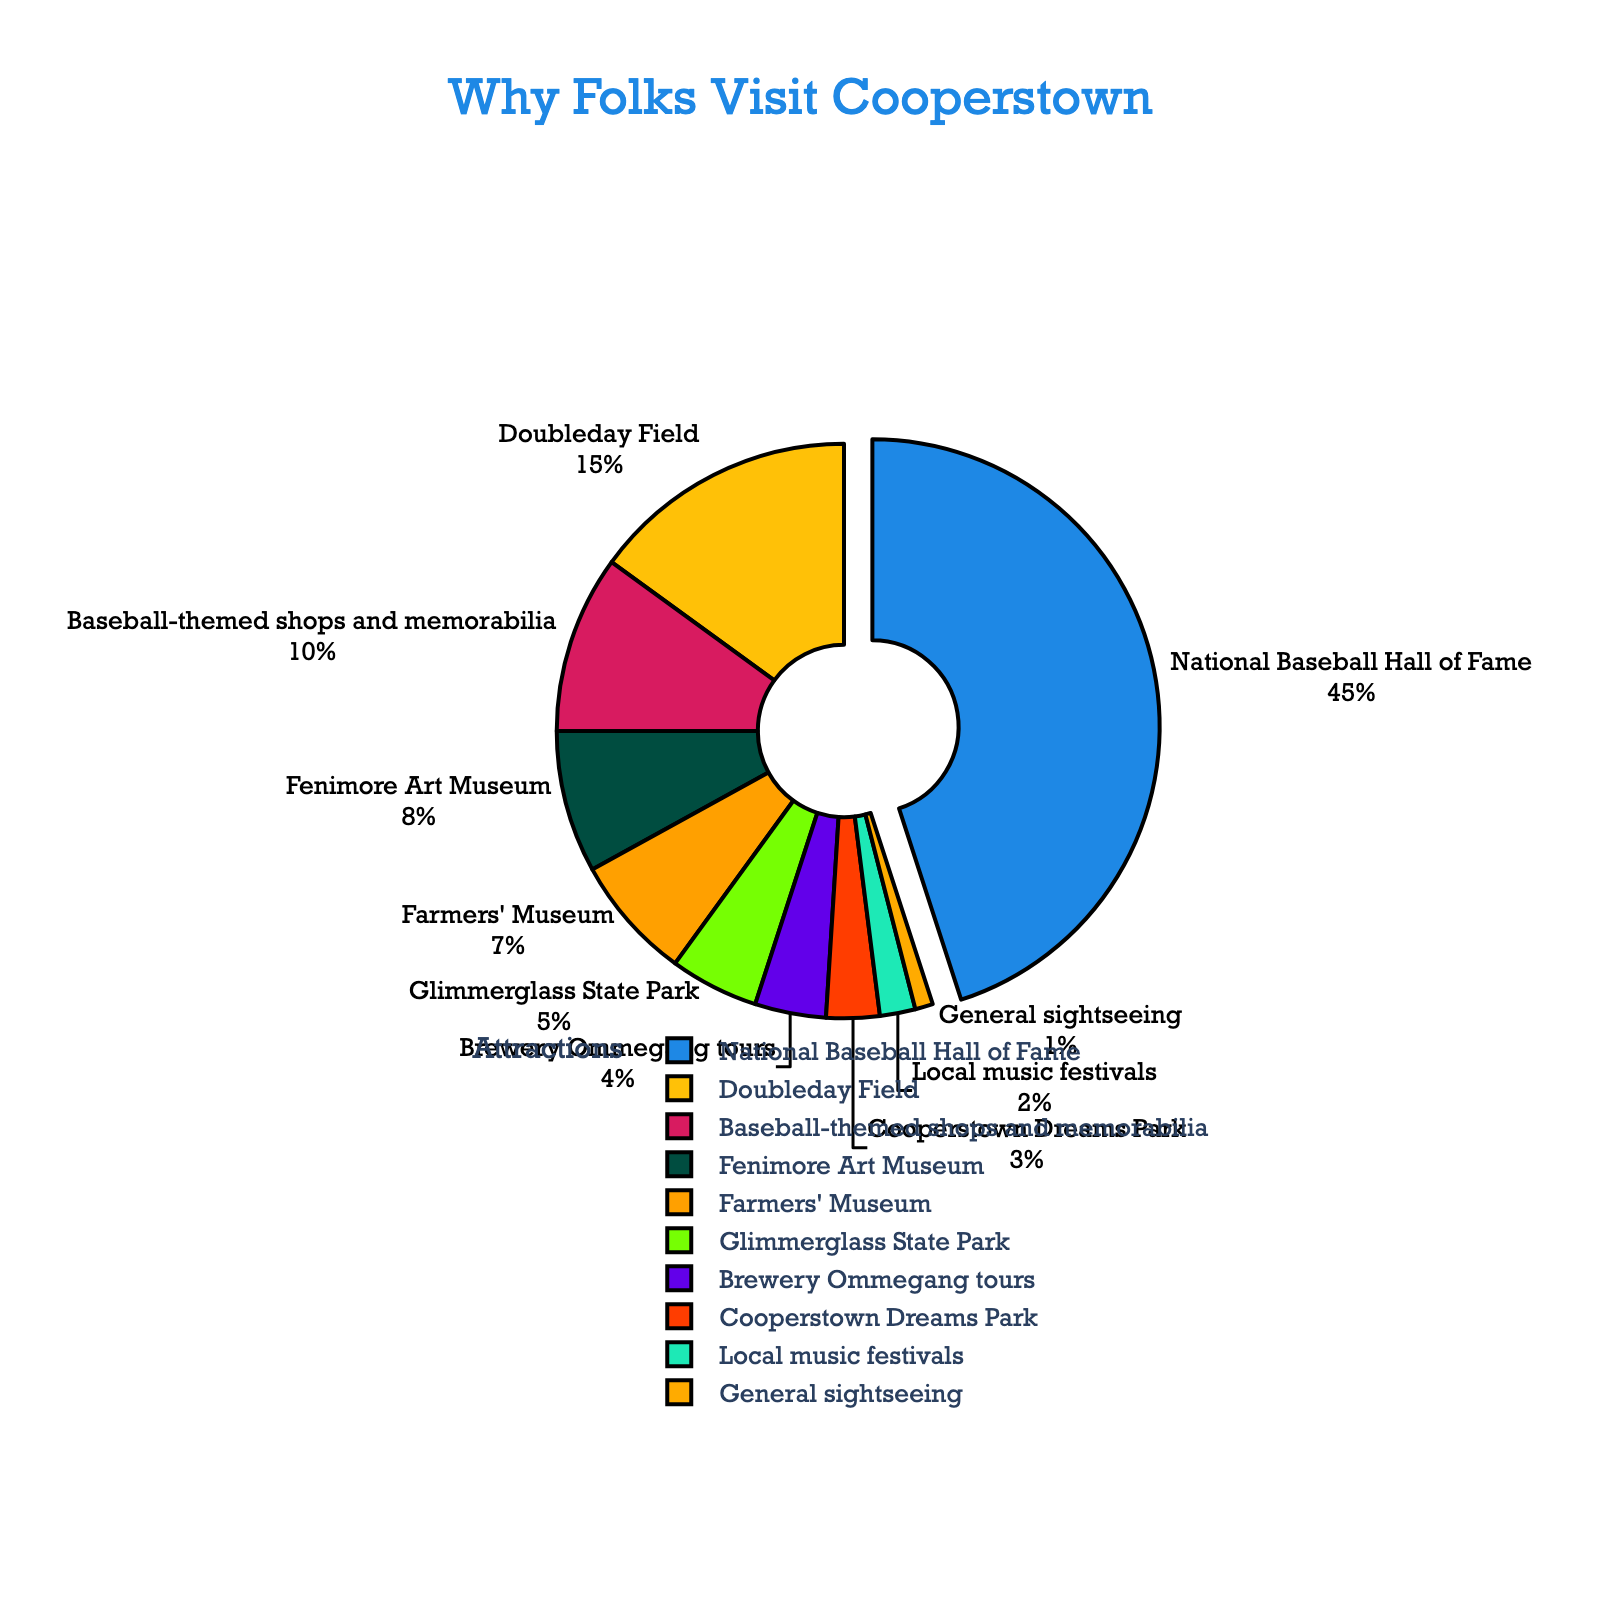What percentage of tourists visit Cooperstown for National Baseball Hall of Fame? The slice of the pie representing the National Baseball Hall of Fame is labeled with a percentage.
Answer: 45% What is the combined percentage of tourists visiting Cooperstown for baseball-related attractions? The baseball-related attractions include the National Baseball Hall of Fame (45%), Doubleday Field (15%), and Baseball-themed shops and memorabilia (10%). Sum these percentages: 45% + 15% + 10% = 70%.
Answer: 70% Which attraction draws the least percentage of tourists? The smallest slice of the pie chart is labeled "General sightseeing" with a percentage of 1%.
Answer: General sightseeing How does the percentage of tourists visiting Doubleday Field compare to those visiting the Farmers' Museum? The slice for Doubleday Field is labeled with 15%, and the slice for the Farmers' Museum is labeled with 7%. 15% is greater than 7%.
Answer: Doubleday Field has a higher percentage What is the total percentage of tourists visiting non-baseball-related attractions? The non-baseball-related attractions are Fenimore Art Museum (8%), Farmers' Museum (7%), Glimmerglass State Park (5%), Brewery Ommegang tours (4%), Cooperstown Dreams Park (3%), Local music festivals (2%), and General sightseeing (1%). Sum these percentages: 8% + 7% + 5% + 4% + 3% + 2% + 1% = 30%.
Answer: 30% What color represents the slice with the second highest percentage? The slice with the second highest percentage is Doubleday Field (15%), and its color is yellow.
Answer: Yellow Is the percentage of tourists visiting Glimmerglass State Park larger or smaller than those visiting Baseball-themed shops and memorabilia? The slice for Glimmerglass State Park is labeled with 5%, and the slice for Baseball-themed shops and memorabilia is labeled with 10%. 5% is smaller than 10%.
Answer: Smaller How many more percentage points does National Baseball Hall of Fame have over Fenimore Art Museum? National Baseball Hall of Fame has 45%, and Fenimore Art Museum has 8%. Subtracting these percentages: 45% - 8% = 37%.
Answer: 37% Which attractions together constitute exactly 50% of the total tourist visits? National Baseball Hall of Fame (45%) and Doubleday Field (15%) together constitute 60%, not 50%. The correct combination is National Baseball Hall of Fame (45%) and Baseball-themed shops and memorabilia (10%), which sum to 55% and not 50%. For an exact 50% from the data given, National Baseball Hall of Fame (45%) and Doubleday Field (15%) could not be added to get exactly 50%. Therefore, there aren’t exact combinations available with these percentages to get precisely 50% in this context.
Answer: Not possible with the given data If Brewery Ommegang tours and Cooperstown Dreams Park combined, would they surpass the percentage of tourists visiting Doubleday Field? Brewery Ommegang tours have 4%, and Cooperstown Dreams Park has 3%. Combined, they make 4% + 3% = 7%, which is less than Doubleday Field's 15%.
Answer: No Based on the pie chart, which reason attracts the most tourists, and what does this indicate about Cooperstown's popularity? The largest slice, representing 45%, corresponds to the National Baseball Hall of Fame, indicating that Cooperstown's popularity is primarily driven by its baseball heritage and attractions.
Answer: National Baseball Hall of Fame 